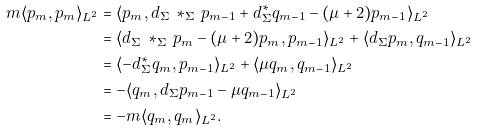<formula> <loc_0><loc_0><loc_500><loc_500>m \langle p _ { m } , p _ { m } \rangle _ { L ^ { 2 } } & = \langle p _ { m } , d _ { \Sigma } \, * _ { \Sigma } \, p _ { m - 1 } + d ^ { * } _ { \Sigma } q _ { m - 1 } - ( \mu + 2 ) p _ { m - 1 } \rangle _ { L ^ { 2 } } \\ & = \langle d _ { \Sigma } \, * _ { \Sigma } \, p _ { m } - ( \mu + 2 ) p _ { m } , p _ { m - 1 } \rangle _ { L ^ { 2 } } + \langle d _ { \Sigma } p _ { m } , q _ { m - 1 } \rangle _ { L ^ { 2 } } \\ & = \langle - d ^ { * } _ { \Sigma } q _ { m } , p _ { m - 1 } \rangle _ { L ^ { 2 } } + \langle \mu q _ { m } , q _ { m - 1 } \rangle _ { L ^ { 2 } } \\ & = - \langle q _ { m } , d _ { \Sigma } p _ { m - 1 } - \mu q _ { m - 1 } \rangle _ { L ^ { 2 } } \\ & = - m \langle q _ { m } , q _ { m } \rangle _ { L ^ { 2 } } .</formula> 